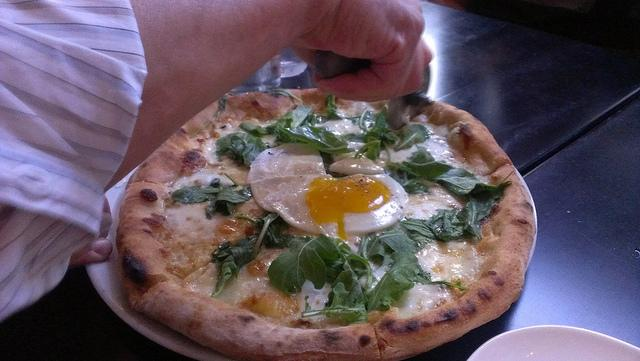What kind of bird created something that sits on this pizza?

Choices:
A) quail
B) sparrow
C) chicken
D) ostrich chicken 